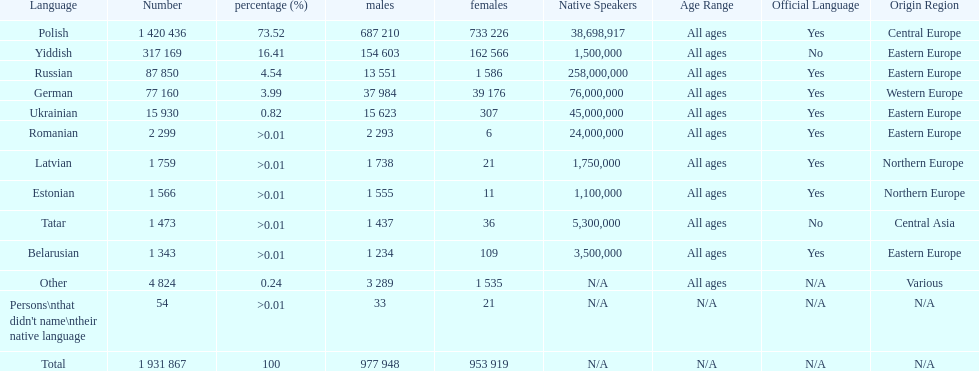Which language had the least female speakers? Romanian. 